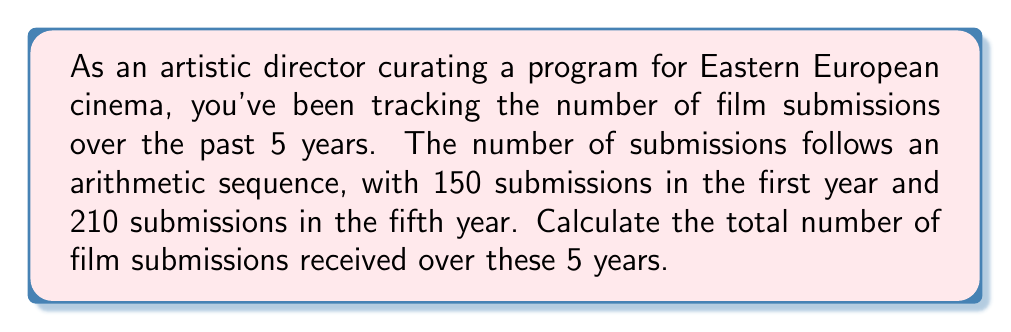Show me your answer to this math problem. Let's approach this step-by-step:

1) First, we need to identify the arithmetic sequence:
   - First term (a₁) = 150
   - Fifth term (a₅) = 210
   - Number of terms (n) = 5

2) In an arithmetic sequence, the difference (d) between each term is constant. We can find this using the formula:
   $$ a_n = a_1 + (n-1)d $$
   
   Substituting our known values:
   $$ 210 = 150 + (5-1)d $$
   $$ 210 = 150 + 4d $$
   $$ 60 = 4d $$
   $$ d = 15 $$

3) Now we know the sequence is: 150, 165, 180, 195, 210

4) To find the sum of this arithmetic sequence, we can use the formula:
   $$ S_n = \frac{n}{2}(a_1 + a_n) $$
   
   Where:
   $S_n$ is the sum of the sequence
   $n$ is the number of terms
   $a_1$ is the first term
   $a_n$ is the last term

5) Substituting our values:
   $$ S_5 = \frac{5}{2}(150 + 210) $$
   $$ S_5 = \frac{5}{2}(360) $$
   $$ S_5 = 5(180) $$
   $$ S_5 = 900 $$

Therefore, the total number of film submissions over the 5 years is 900.
Answer: 900 film submissions 